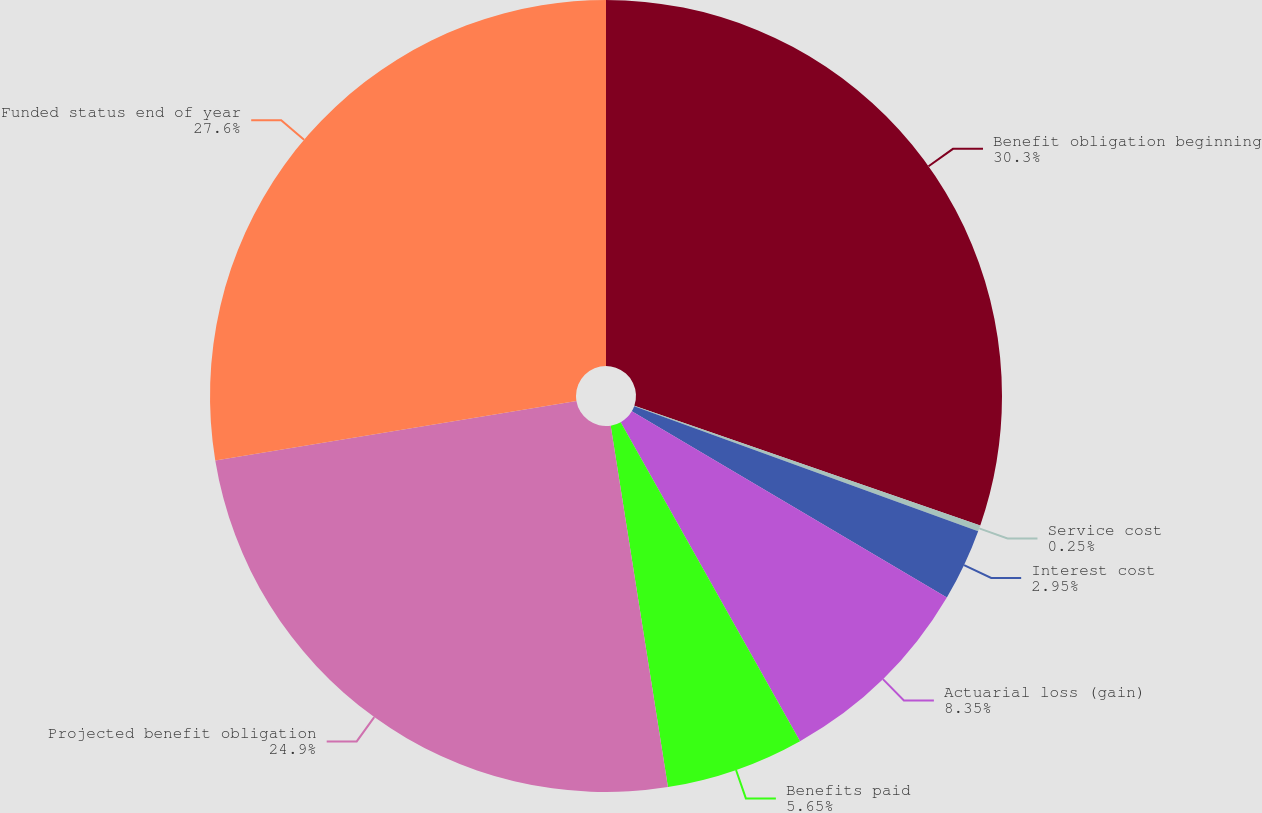Convert chart. <chart><loc_0><loc_0><loc_500><loc_500><pie_chart><fcel>Benefit obligation beginning<fcel>Service cost<fcel>Interest cost<fcel>Actuarial loss (gain)<fcel>Benefits paid<fcel>Projected benefit obligation<fcel>Funded status end of year<nl><fcel>30.3%<fcel>0.25%<fcel>2.95%<fcel>8.35%<fcel>5.65%<fcel>24.9%<fcel>27.6%<nl></chart> 